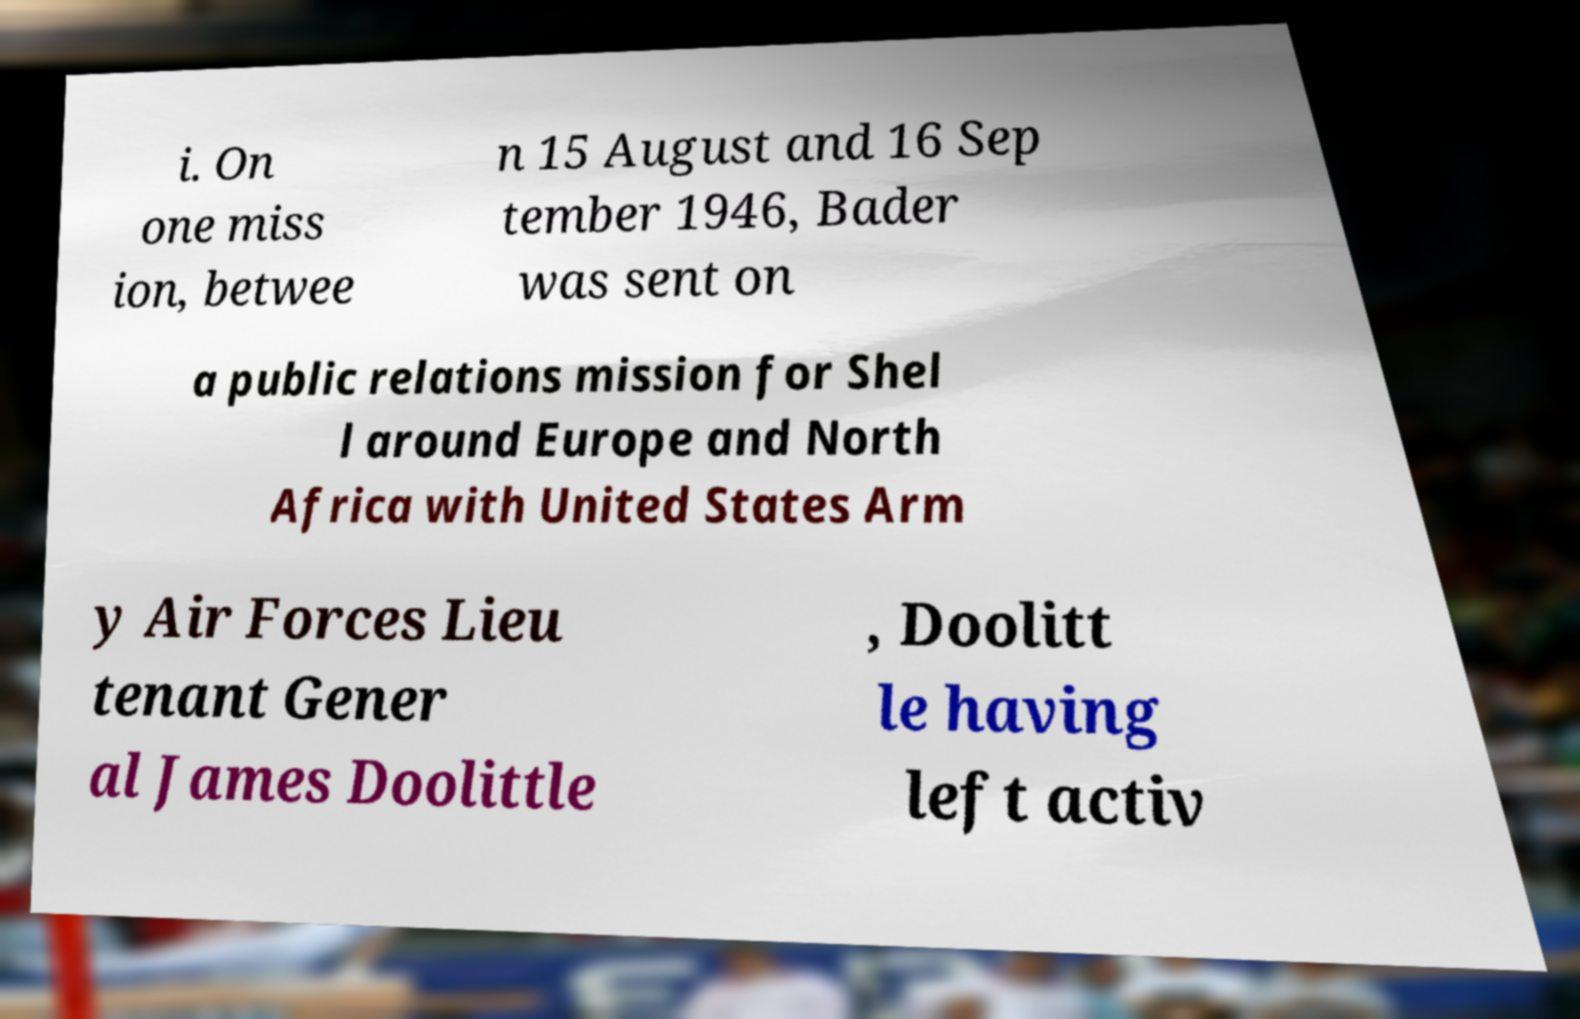Could you assist in decoding the text presented in this image and type it out clearly? i. On one miss ion, betwee n 15 August and 16 Sep tember 1946, Bader was sent on a public relations mission for Shel l around Europe and North Africa with United States Arm y Air Forces Lieu tenant Gener al James Doolittle , Doolitt le having left activ 